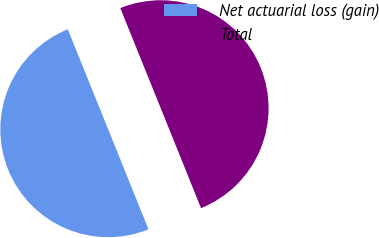Convert chart. <chart><loc_0><loc_0><loc_500><loc_500><pie_chart><fcel>Net actuarial loss (gain)<fcel>Total<nl><fcel>49.99%<fcel>50.01%<nl></chart> 